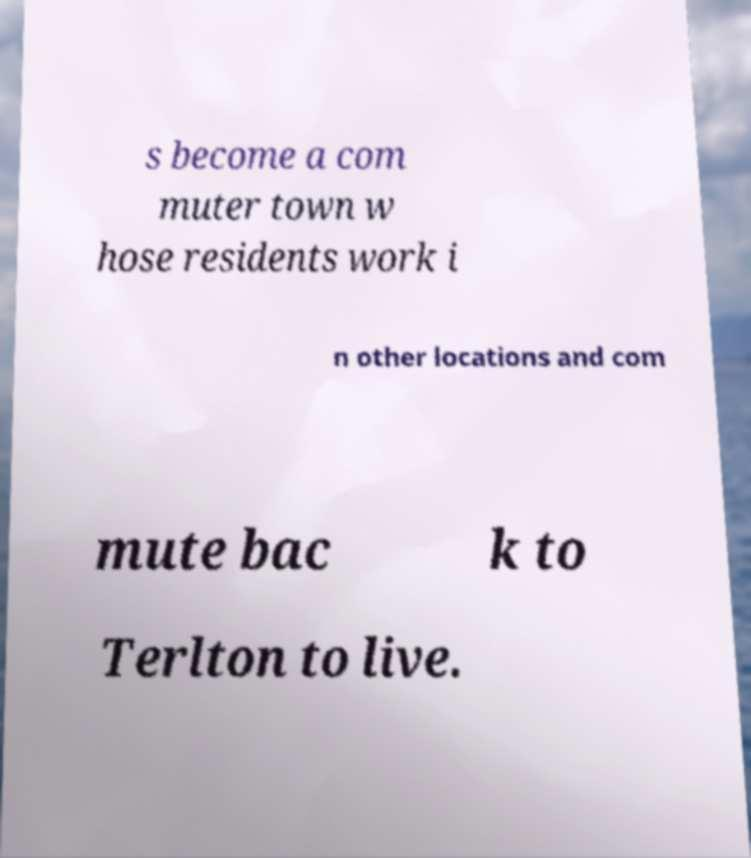Can you read and provide the text displayed in the image?This photo seems to have some interesting text. Can you extract and type it out for me? s become a com muter town w hose residents work i n other locations and com mute bac k to Terlton to live. 